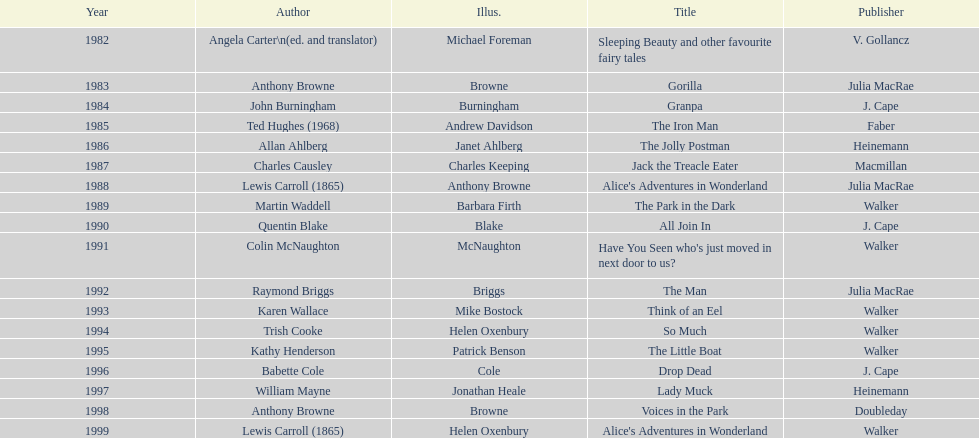Which illustrator was responsible for the last award winner? Helen Oxenbury. 